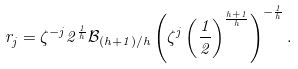<formula> <loc_0><loc_0><loc_500><loc_500>r _ { j } = \zeta ^ { - j } 2 ^ { \frac { 1 } { h } } \mathcal { B } _ { ( h + 1 ) / h } \left ( \zeta ^ { j } \left ( \frac { 1 } { 2 } \right ) ^ { \frac { h + 1 } { h } } \right ) ^ { - \frac { 1 } { h } } .</formula> 